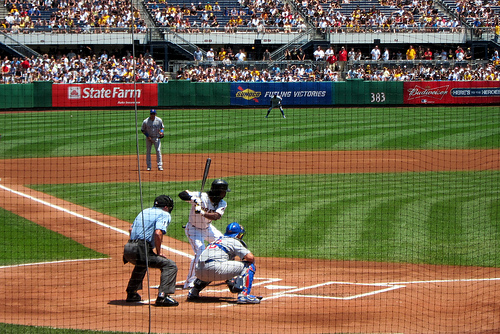<image>
Can you confirm if the catcher is behind the batter? Yes. From this viewpoint, the catcher is positioned behind the batter, with the batter partially or fully occluding the catcher. Is the bat in front of the player? No. The bat is not in front of the player. The spatial positioning shows a different relationship between these objects. Is the helmet above the man? No. The helmet is not positioned above the man. The vertical arrangement shows a different relationship. 